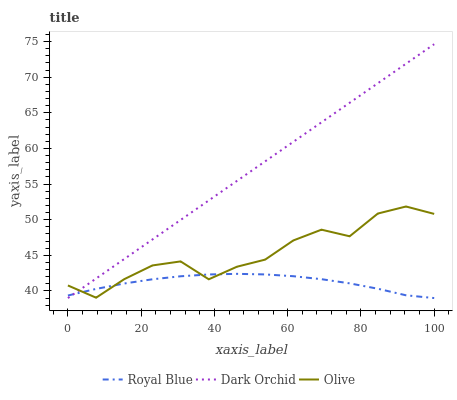Does Royal Blue have the minimum area under the curve?
Answer yes or no. Yes. Does Dark Orchid have the maximum area under the curve?
Answer yes or no. Yes. Does Dark Orchid have the minimum area under the curve?
Answer yes or no. No. Does Royal Blue have the maximum area under the curve?
Answer yes or no. No. Is Dark Orchid the smoothest?
Answer yes or no. Yes. Is Olive the roughest?
Answer yes or no. Yes. Is Royal Blue the smoothest?
Answer yes or no. No. Is Royal Blue the roughest?
Answer yes or no. No. Does Dark Orchid have the highest value?
Answer yes or no. Yes. Does Royal Blue have the highest value?
Answer yes or no. No. Does Olive intersect Dark Orchid?
Answer yes or no. Yes. Is Olive less than Dark Orchid?
Answer yes or no. No. Is Olive greater than Dark Orchid?
Answer yes or no. No. 